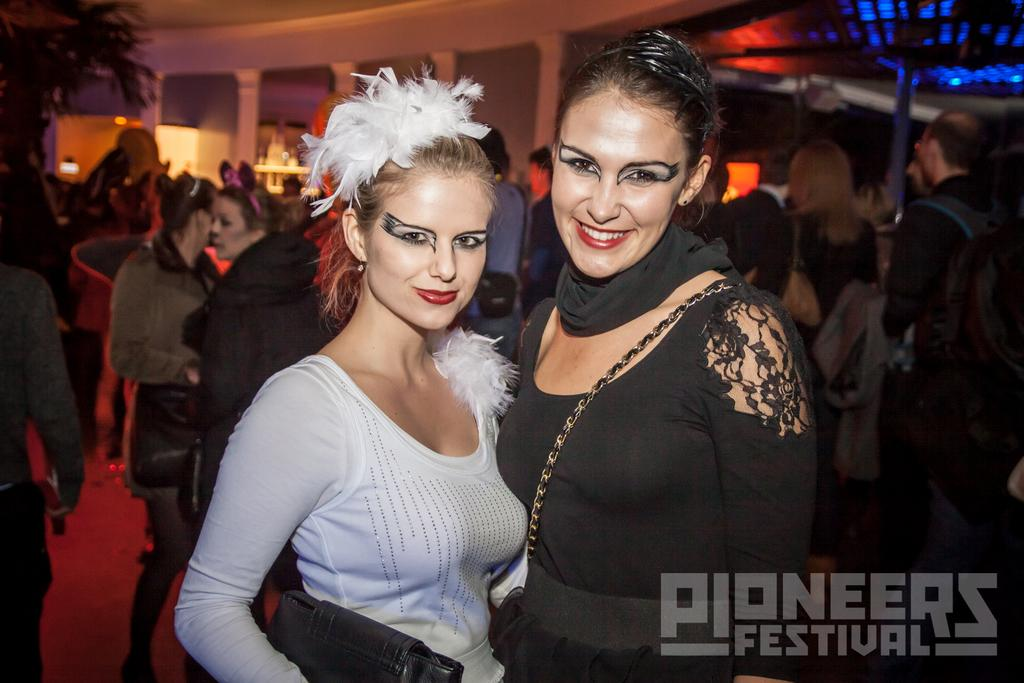How many people are in the image? There is a group of people in the image, but the exact number cannot be determined from the provided facts. What architectural feature can be seen in the image? There are pillars visible in the image. What type of vegetation is present in the image? There is a tree in the image. What might be used for illumination in the image? Lights are present in the image. What grade of wine is being served in the image? There is no wine present in the image, so it is not possible to determine the grade of wine being served. 